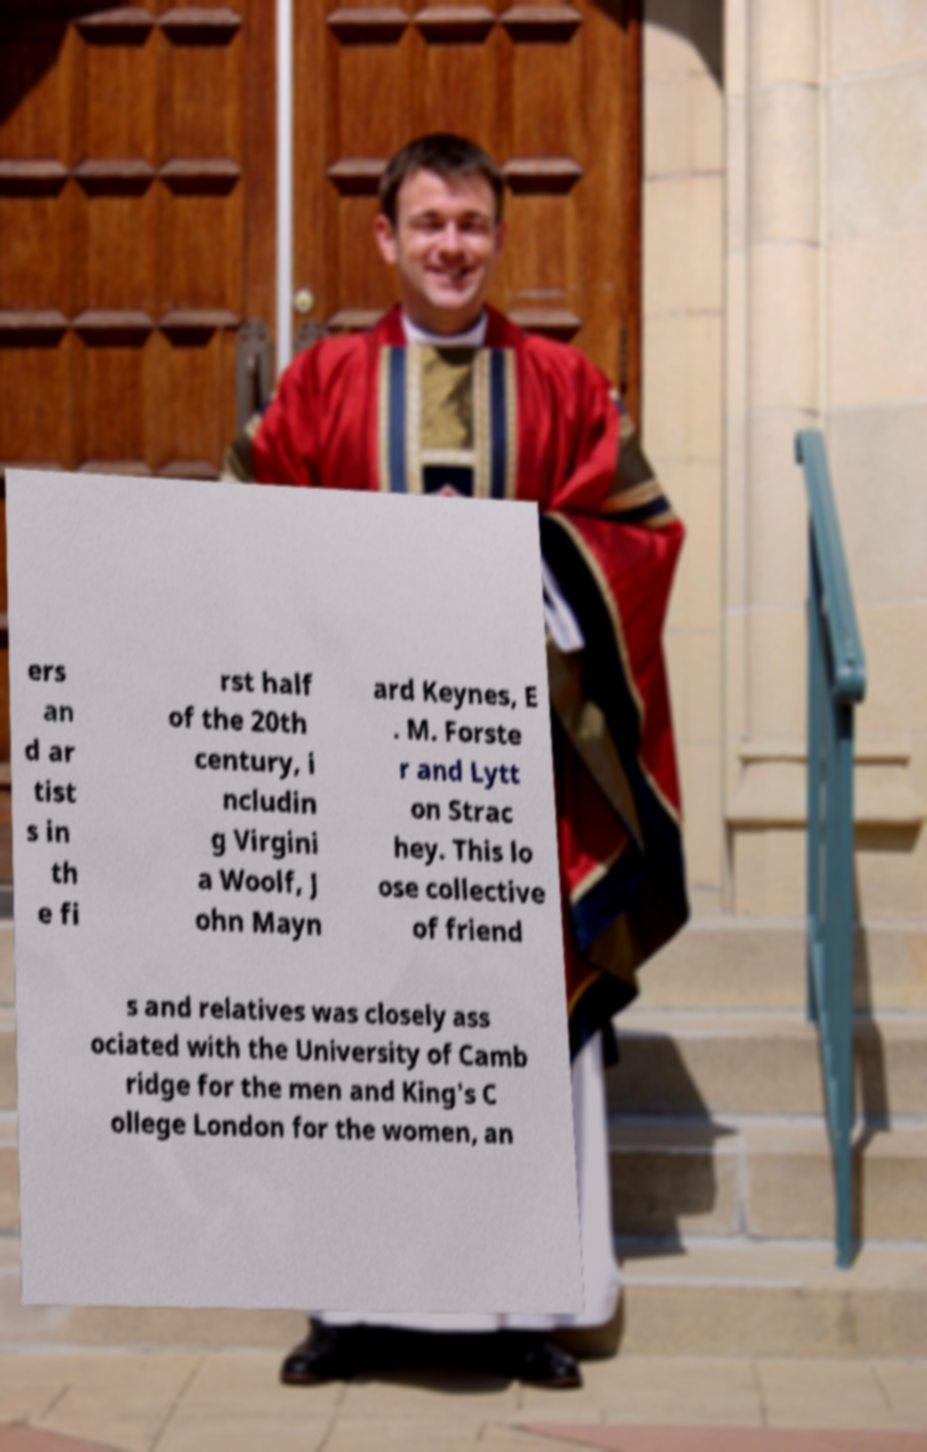What messages or text are displayed in this image? I need them in a readable, typed format. ers an d ar tist s in th e fi rst half of the 20th century, i ncludin g Virgini a Woolf, J ohn Mayn ard Keynes, E . M. Forste r and Lytt on Strac hey. This lo ose collective of friend s and relatives was closely ass ociated with the University of Camb ridge for the men and King's C ollege London for the women, an 